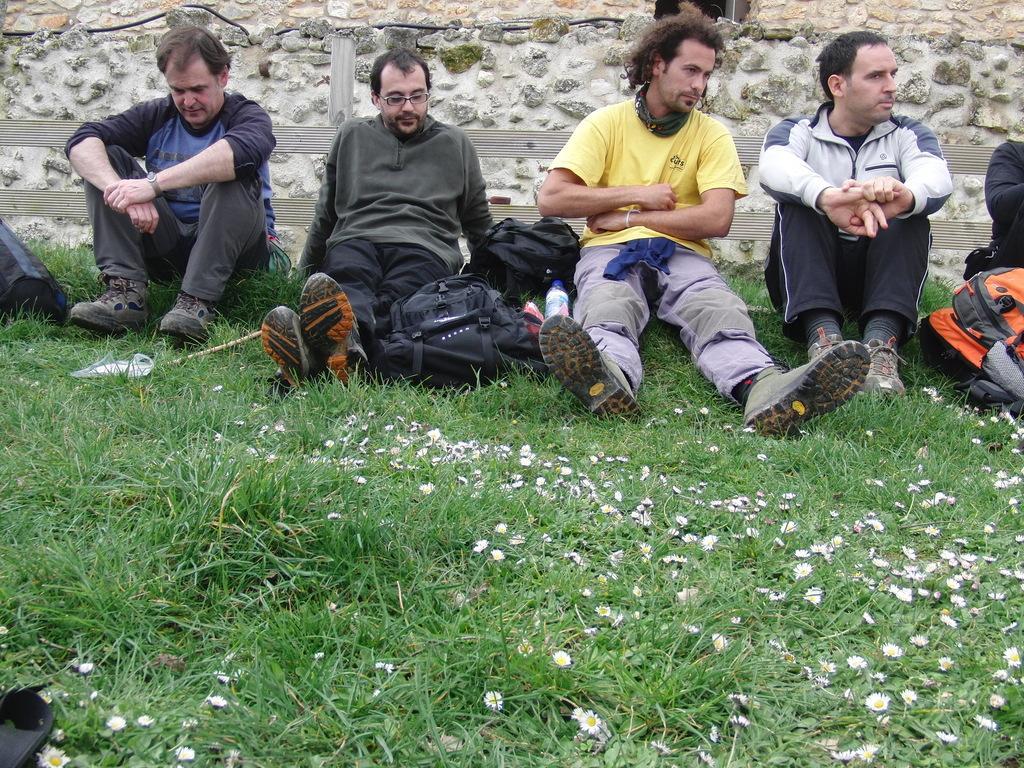Please provide a concise description of this image. In this picture I can see few people sitting on the grass. I can see bags, flowers and some other objects, and in the background there is fence and a wall. 